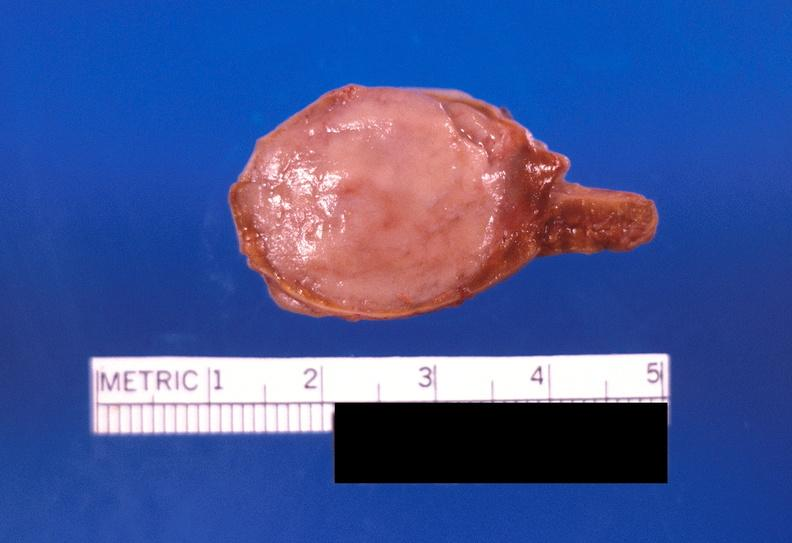does this image show adrenal medullary tumor?
Answer the question using a single word or phrase. Yes 